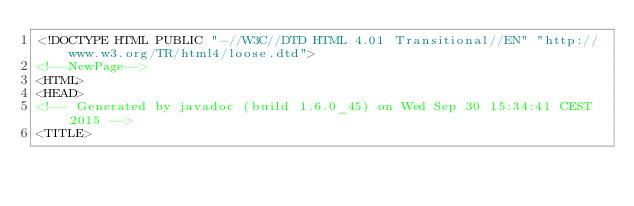Convert code to text. <code><loc_0><loc_0><loc_500><loc_500><_HTML_><!DOCTYPE HTML PUBLIC "-//W3C//DTD HTML 4.01 Transitional//EN" "http://www.w3.org/TR/html4/loose.dtd">
<!--NewPage-->
<HTML>
<HEAD>
<!-- Generated by javadoc (build 1.6.0_45) on Wed Sep 30 15:34:41 CEST 2015 -->
<TITLE></code> 